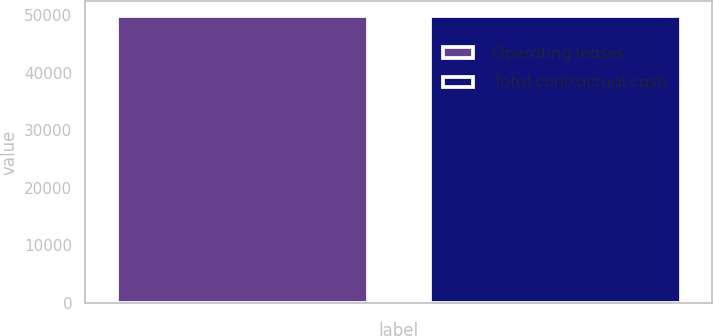Convert chart. <chart><loc_0><loc_0><loc_500><loc_500><bar_chart><fcel>Operating leases<fcel>Total contractual cash<nl><fcel>49949<fcel>49949.1<nl></chart> 